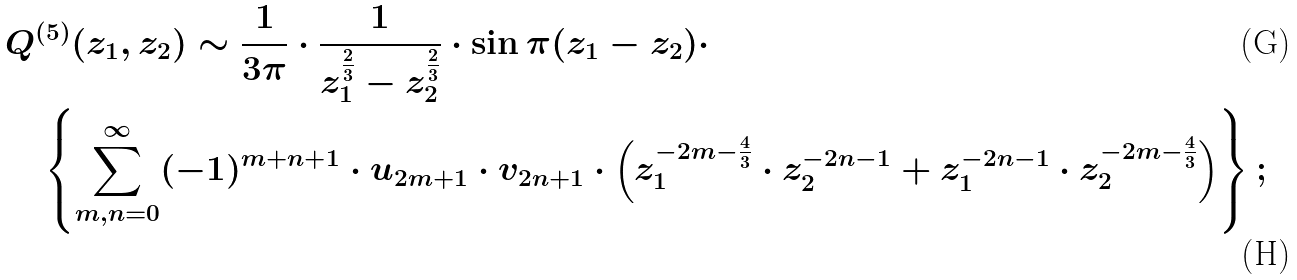<formula> <loc_0><loc_0><loc_500><loc_500>& Q ^ { ( 5 ) } ( z _ { 1 } , z _ { 2 } ) \sim \frac { 1 } { 3 \pi } \cdot \frac { 1 } { z _ { 1 } ^ { \frac { 2 } { 3 } } - z _ { 2 } ^ { \frac { 2 } { 3 } } } \cdot \sin \pi ( z _ { 1 } - z _ { 2 } ) \cdot \\ & \quad \left \{ \sum ^ { \infty } _ { m , n = 0 } ( - 1 ) ^ { m + n + 1 } \cdot u _ { 2 m + 1 } \cdot v _ { 2 n + 1 } \cdot \left ( z _ { 1 } ^ { - 2 m - \frac { 4 } { 3 } } \cdot z _ { 2 } ^ { - 2 n - 1 } + z _ { 1 } ^ { - 2 n - 1 } \cdot z _ { 2 } ^ { - 2 m - \frac { 4 } { 3 } } \right ) \right \} ;</formula> 